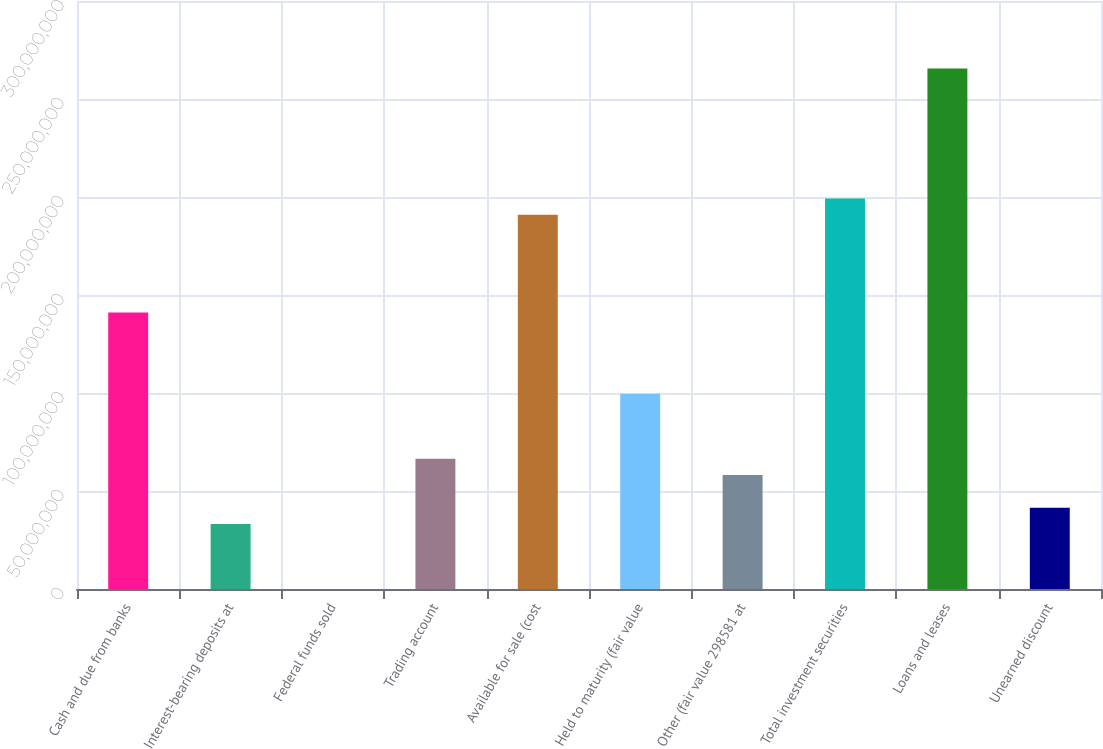Convert chart. <chart><loc_0><loc_0><loc_500><loc_500><bar_chart><fcel>Cash and due from banks<fcel>Interest-bearing deposits at<fcel>Federal funds sold<fcel>Trading account<fcel>Available for sale (cost<fcel>Held to maturity (fair value<fcel>Other (fair value 298581 at<fcel>Total investment securities<fcel>Loans and leases<fcel>Unearned discount<nl><fcel>1.41113e+08<fcel>3.32053e+07<fcel>3000<fcel>6.64076e+07<fcel>1.90916e+08<fcel>9.961e+07<fcel>5.81071e+07<fcel>1.99217e+08<fcel>2.65622e+08<fcel>4.15059e+07<nl></chart> 